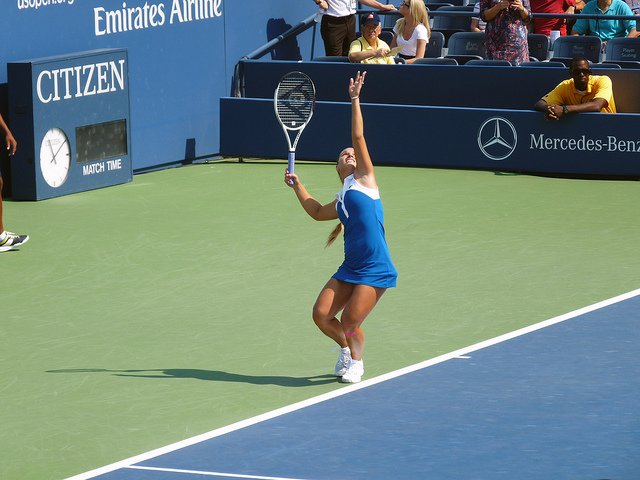Please extract the text content from this image. CITIZEN Emirates Airline Mercedes-Benz MATCH 